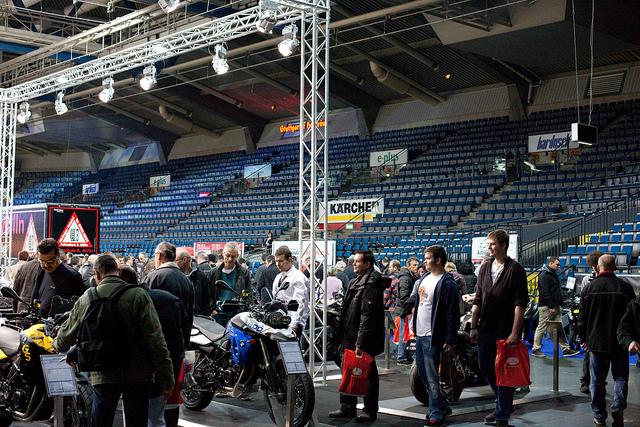What are the people inside of?
Write a very short answer. Stadium. What vehicles are shown?
Quick response, please. Motorcycles. What color are the two bags that look alike?
Answer briefly. Red. 